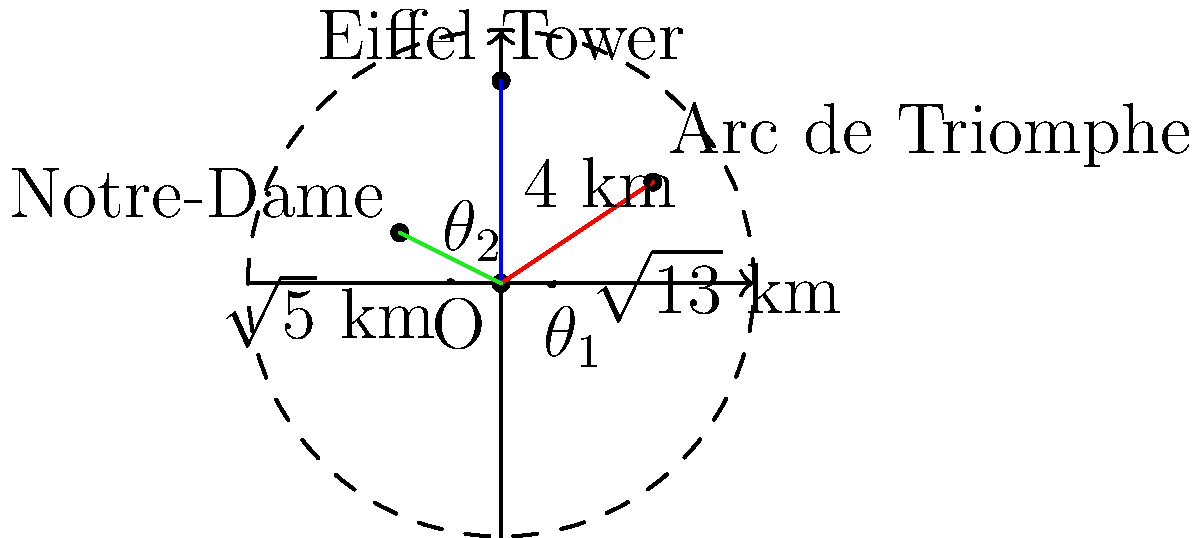Dans le contexte de la défense nationale, il est crucial de connaître la position exacte des monuments emblématiques de Paris. En utilisant la Tour Eiffel comme point de référence (0°, 4 km) dans un système de coordonnées polaires, déterminez :

a) L'angle $\theta_1$ et la distance de l'Arc de Triomphe par rapport à la Tour Eiffel.
b) L'angle $\theta_2$ et la distance de Notre-Dame par rapport à la Tour Eiffel.

Arrondissez vos réponses au degré et au kilomètre près. Pour résoudre ce problème, nous allons utiliser les coordonnées cartésiennes données et les convertir en coordonnées polaires.

a) Pour l'Arc de Triomphe :
   Coordonnées cartésiennes : (3, 2)
   1. Distance : $r_1 = \sqrt{3^2 + 2^2} = \sqrt{13} \approx 3.61$ km
   2. Angle : $\theta_1 = \arctan(\frac{2}{3}) \approx 33.69°$

b) Pour Notre-Dame :
   Coordonnées cartésiennes : (-2, 1)
   1. Distance : $r_2 = \sqrt{(-2)^2 + 1^2} = \sqrt{5} \approx 2.24$ km
   2. Angle : $\theta_2 = \arctan(\frac{1}{-2}) + 180° \approx 153.43°$

Arrondi au degré et au kilomètre près :
a) Arc de Triomphe : 34°, 4 km
b) Notre-Dame : 153°, 2 km
Answer: a) 34°, 4 km  b) 153°, 2 km 